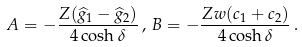<formula> <loc_0><loc_0><loc_500><loc_500>A = - \frac { Z ( \widehat { g } _ { 1 } - \widehat { g } _ { 2 } ) } { 4 \cosh \delta } \, , \, B = - \frac { Z w ( c _ { 1 } + c _ { 2 } ) } { 4 \cosh \delta } \, .</formula> 